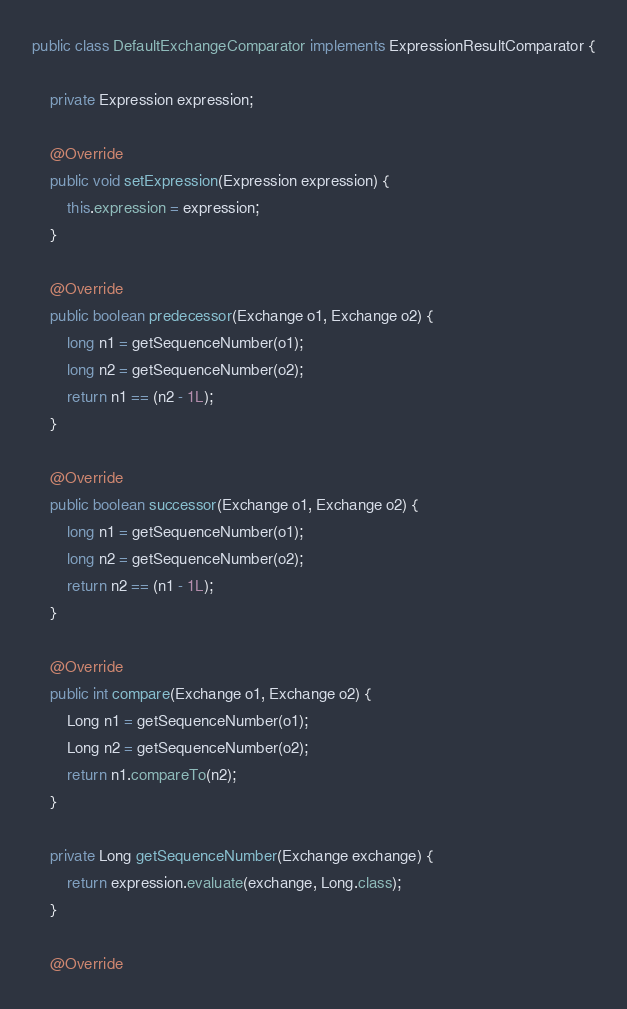Convert code to text. <code><loc_0><loc_0><loc_500><loc_500><_Java_>public class DefaultExchangeComparator implements ExpressionResultComparator {

    private Expression expression;

    @Override
    public void setExpression(Expression expression) {
        this.expression = expression;
    }

    @Override
    public boolean predecessor(Exchange o1, Exchange o2) {
        long n1 = getSequenceNumber(o1);
        long n2 = getSequenceNumber(o2);
        return n1 == (n2 - 1L);
    }

    @Override
    public boolean successor(Exchange o1, Exchange o2) {
        long n1 = getSequenceNumber(o1);
        long n2 = getSequenceNumber(o2);
        return n2 == (n1 - 1L);
    }

    @Override
    public int compare(Exchange o1, Exchange o2) {
        Long n1 = getSequenceNumber(o1);
        Long n2 = getSequenceNumber(o2);
        return n1.compareTo(n2);
    }

    private Long getSequenceNumber(Exchange exchange) {
        return expression.evaluate(exchange, Long.class);
    }

    @Override</code> 